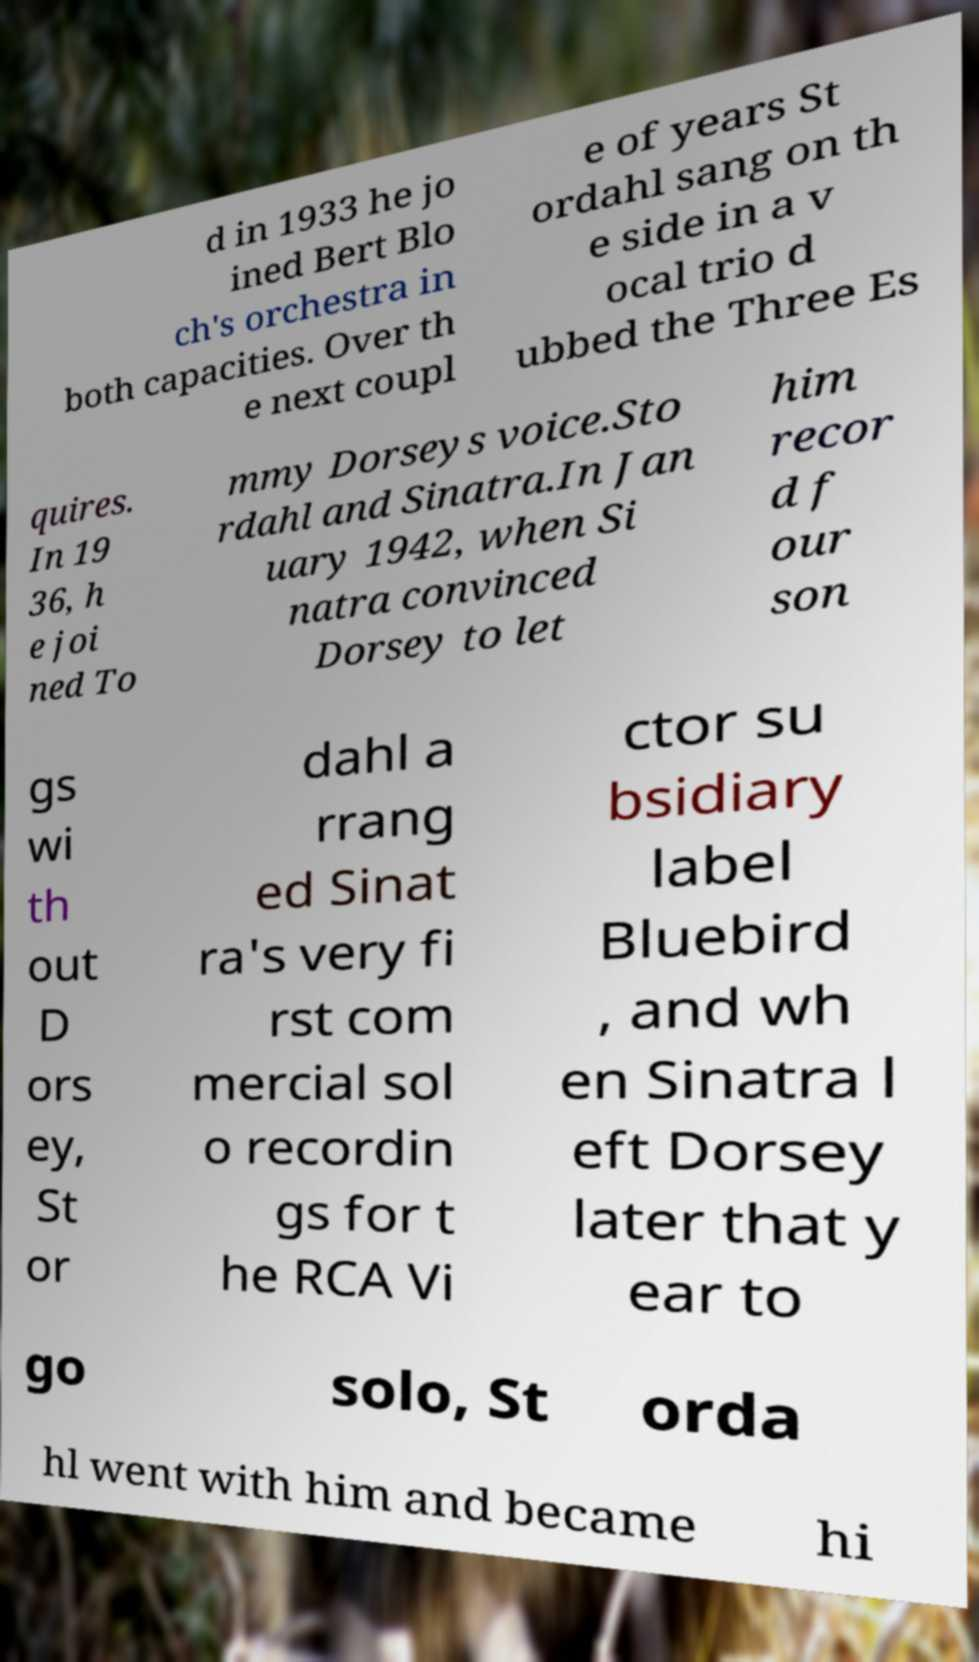Could you extract and type out the text from this image? d in 1933 he jo ined Bert Blo ch's orchestra in both capacities. Over th e next coupl e of years St ordahl sang on th e side in a v ocal trio d ubbed the Three Es quires. In 19 36, h e joi ned To mmy Dorseys voice.Sto rdahl and Sinatra.In Jan uary 1942, when Si natra convinced Dorsey to let him recor d f our son gs wi th out D ors ey, St or dahl a rrang ed Sinat ra's very fi rst com mercial sol o recordin gs for t he RCA Vi ctor su bsidiary label Bluebird , and wh en Sinatra l eft Dorsey later that y ear to go solo, St orda hl went with him and became hi 